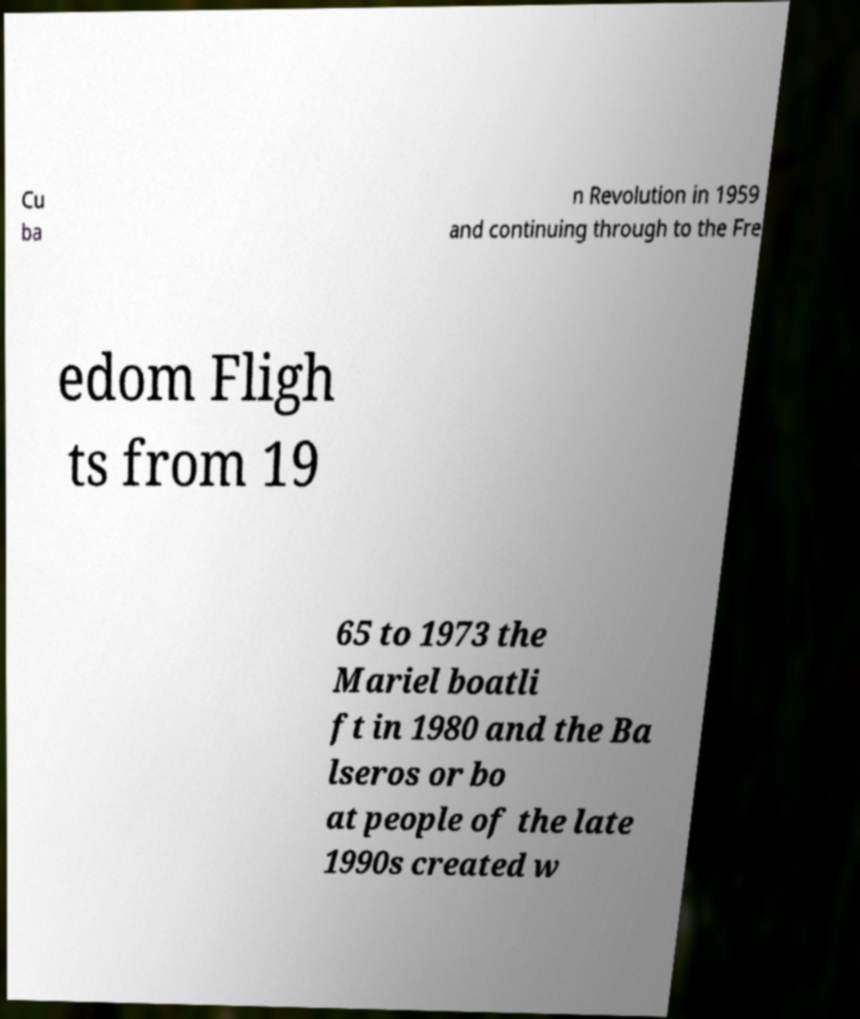Please read and relay the text visible in this image. What does it say? Cu ba n Revolution in 1959 and continuing through to the Fre edom Fligh ts from 19 65 to 1973 the Mariel boatli ft in 1980 and the Ba lseros or bo at people of the late 1990s created w 